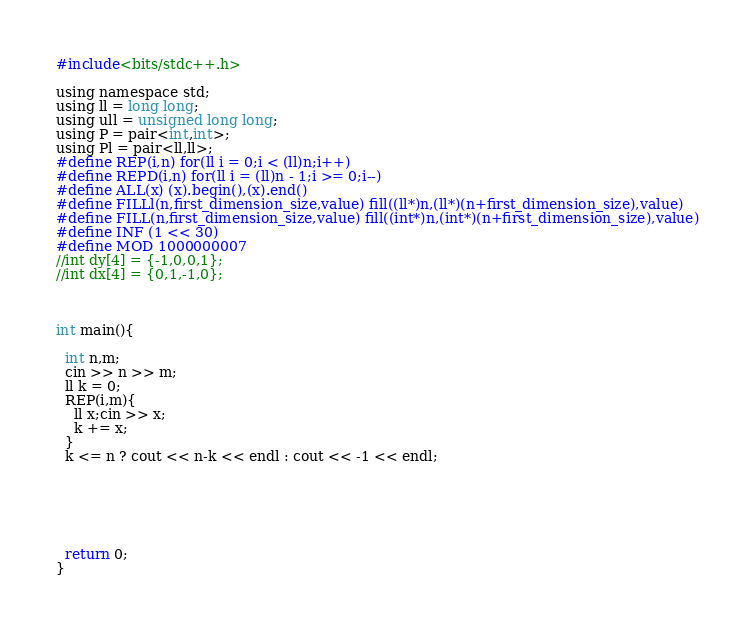<code> <loc_0><loc_0><loc_500><loc_500><_C_>#include<bits/stdc++.h>

using namespace std;
using ll = long long;
using ull = unsigned long long;
using P = pair<int,int>;
using Pl = pair<ll,ll>;
#define REP(i,n) for(ll i = 0;i < (ll)n;i++)
#define REPD(i,n) for(ll i = (ll)n - 1;i >= 0;i--)
#define ALL(x) (x).begin(),(x).end()
#define FILLl(n,first_dimension_size,value) fill((ll*)n,(ll*)(n+first_dimension_size),value)
#define FILL(n,first_dimension_size,value) fill((int*)n,(int*)(n+first_dimension_size),value)
#define INF (1 << 30)
#define MOD 1000000007
//int dy[4] = {-1,0,0,1};
//int dx[4] = {0,1,-1,0};



int main(){

  int n,m;
  cin >> n >> m;
  ll k = 0;
  REP(i,m){
    ll x;cin >> x;
    k += x;
  }
  k <= n ? cout << n-k << endl : cout << -1 << endl;

  


  

  return 0;
}
</code> 